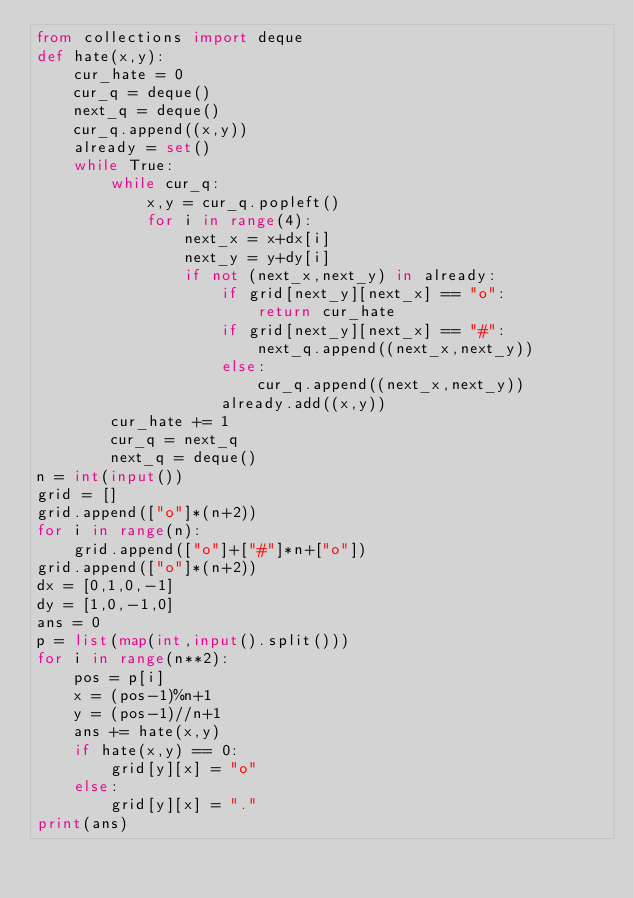<code> <loc_0><loc_0><loc_500><loc_500><_Python_>from collections import deque
def hate(x,y):
    cur_hate = 0
    cur_q = deque()
    next_q = deque()
    cur_q.append((x,y))
    already = set()
    while True:
        while cur_q:
            x,y = cur_q.popleft()
            for i in range(4):
                next_x = x+dx[i]
                next_y = y+dy[i]
                if not (next_x,next_y) in already:
                    if grid[next_y][next_x] == "o":
                        return cur_hate
                    if grid[next_y][next_x] == "#":
                        next_q.append((next_x,next_y))
                    else:
                        cur_q.append((next_x,next_y))
                    already.add((x,y))
        cur_hate += 1
        cur_q = next_q
        next_q = deque()
n = int(input())
grid = []
grid.append(["o"]*(n+2))
for i in range(n):
    grid.append(["o"]+["#"]*n+["o"])
grid.append(["o"]*(n+2))
dx = [0,1,0,-1]
dy = [1,0,-1,0]
ans = 0
p = list(map(int,input().split()))
for i in range(n**2):
    pos = p[i]
    x = (pos-1)%n+1
    y = (pos-1)//n+1
    ans += hate(x,y)
    if hate(x,y) == 0:
        grid[y][x] = "o"
    else:
        grid[y][x] = "."
print(ans)</code> 